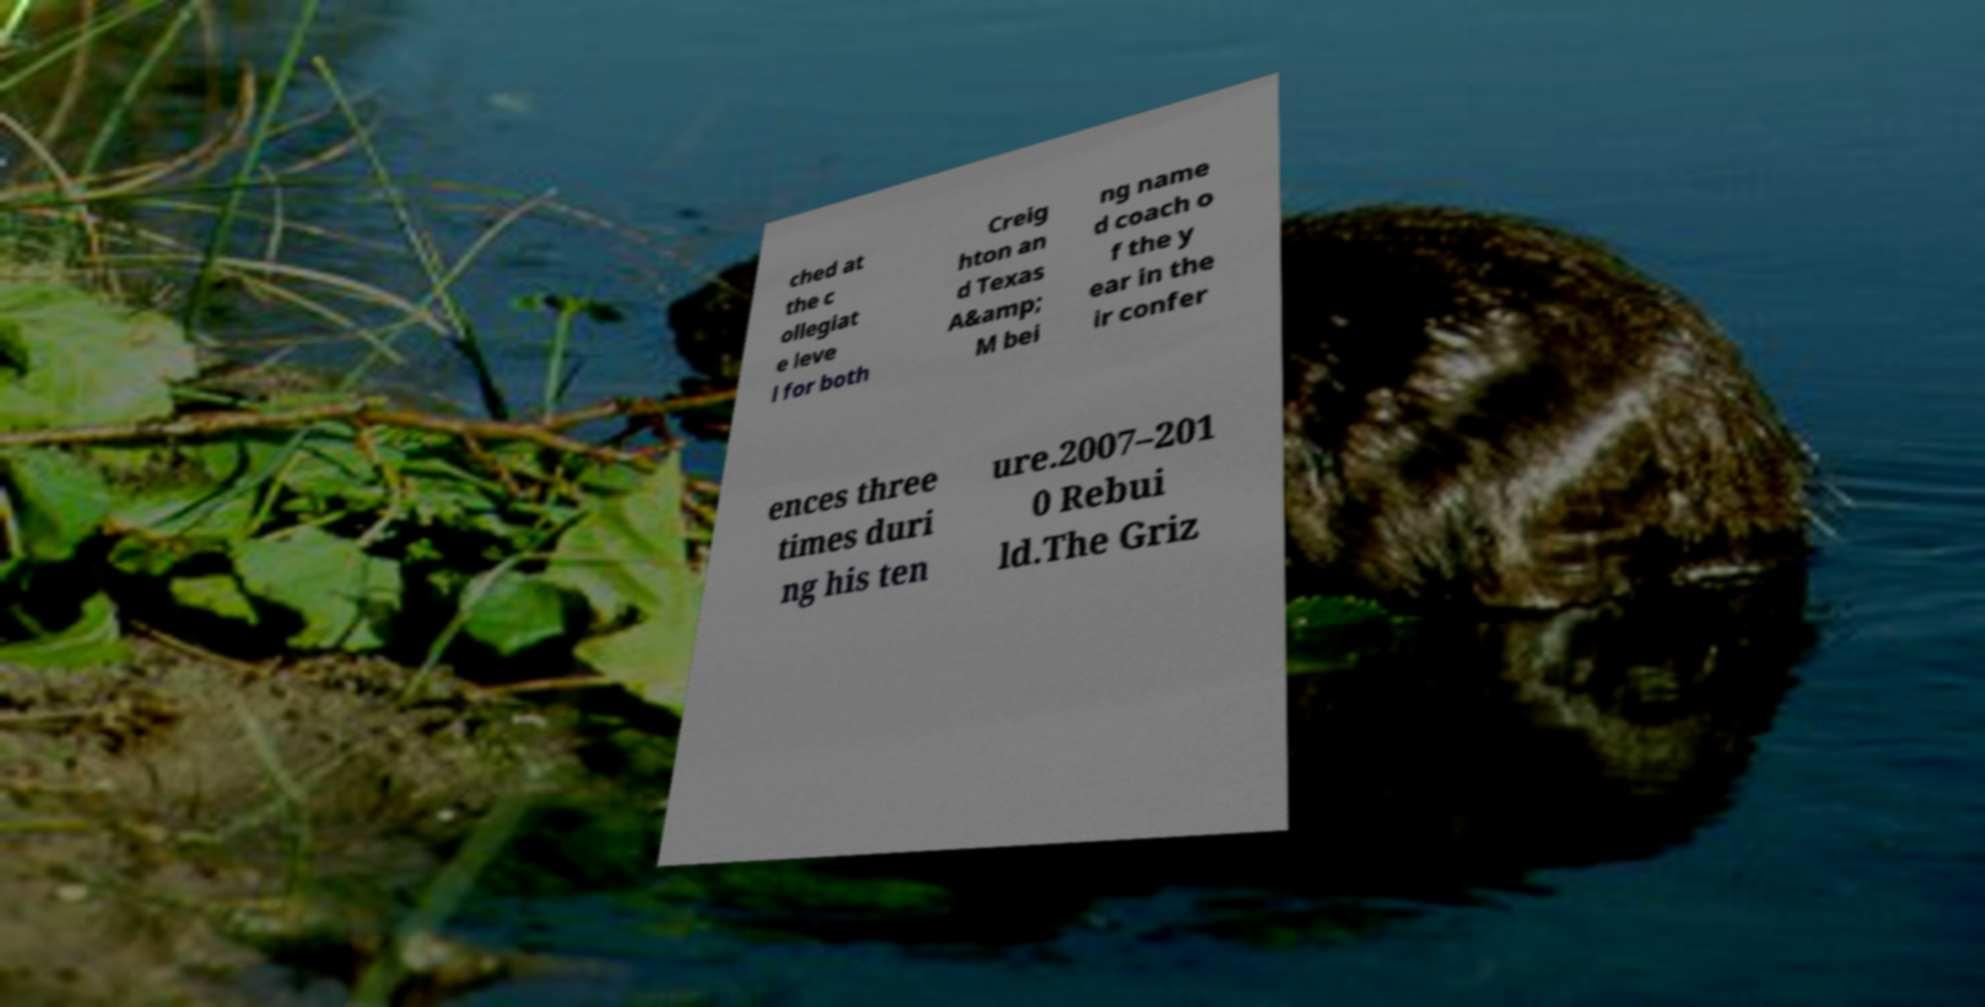For documentation purposes, I need the text within this image transcribed. Could you provide that? ched at the c ollegiat e leve l for both Creig hton an d Texas A&amp; M bei ng name d coach o f the y ear in the ir confer ences three times duri ng his ten ure.2007–201 0 Rebui ld.The Griz 